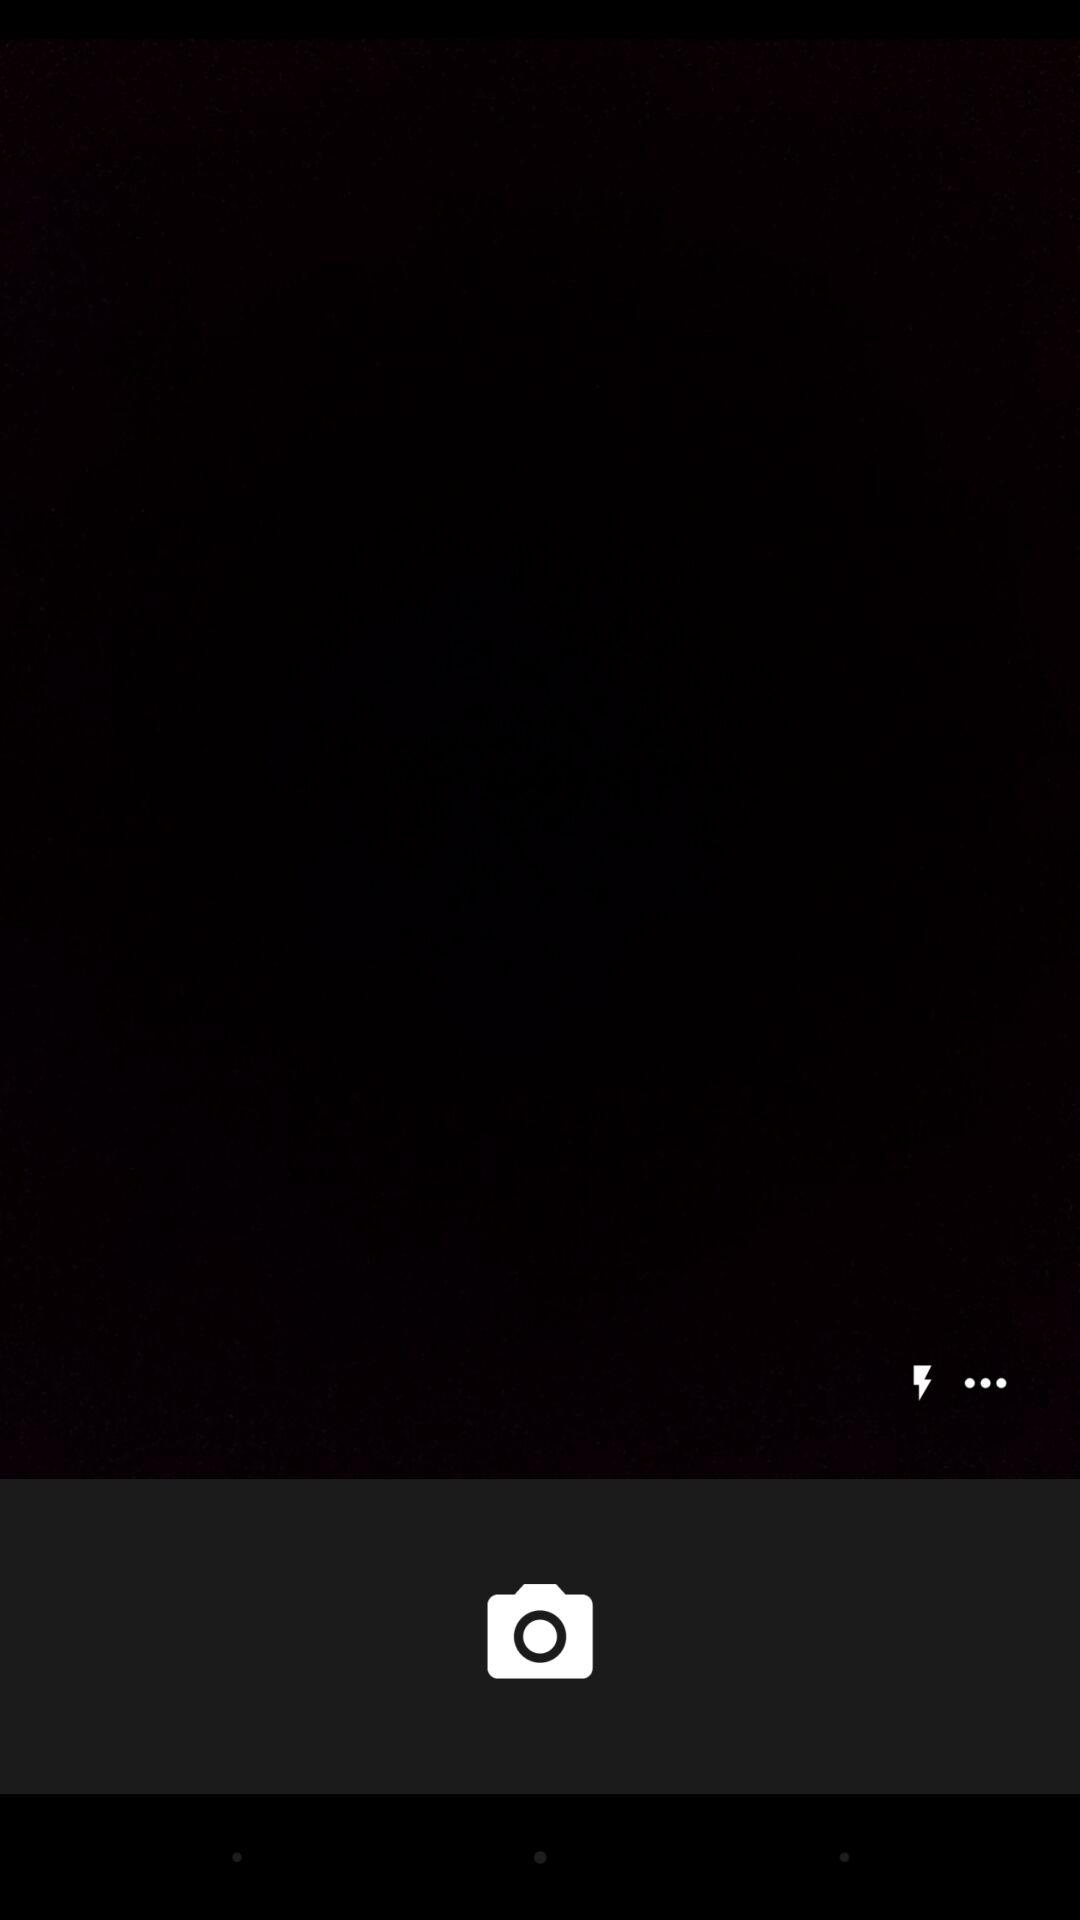How many more dots are there than lightning bolts?
Answer the question using a single word or phrase. 2 